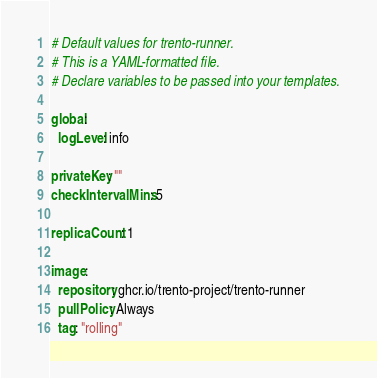<code> <loc_0><loc_0><loc_500><loc_500><_YAML_># Default values for trento-runner.
# This is a YAML-formatted file.
# Declare variables to be passed into your templates.

global:
  logLevel: info

privateKey: ""
checkIntervalMins: 5

replicaCount: 1

image:
  repository: ghcr.io/trento-project/trento-runner
  pullPolicy: Always
  tag: "rolling"
</code> 